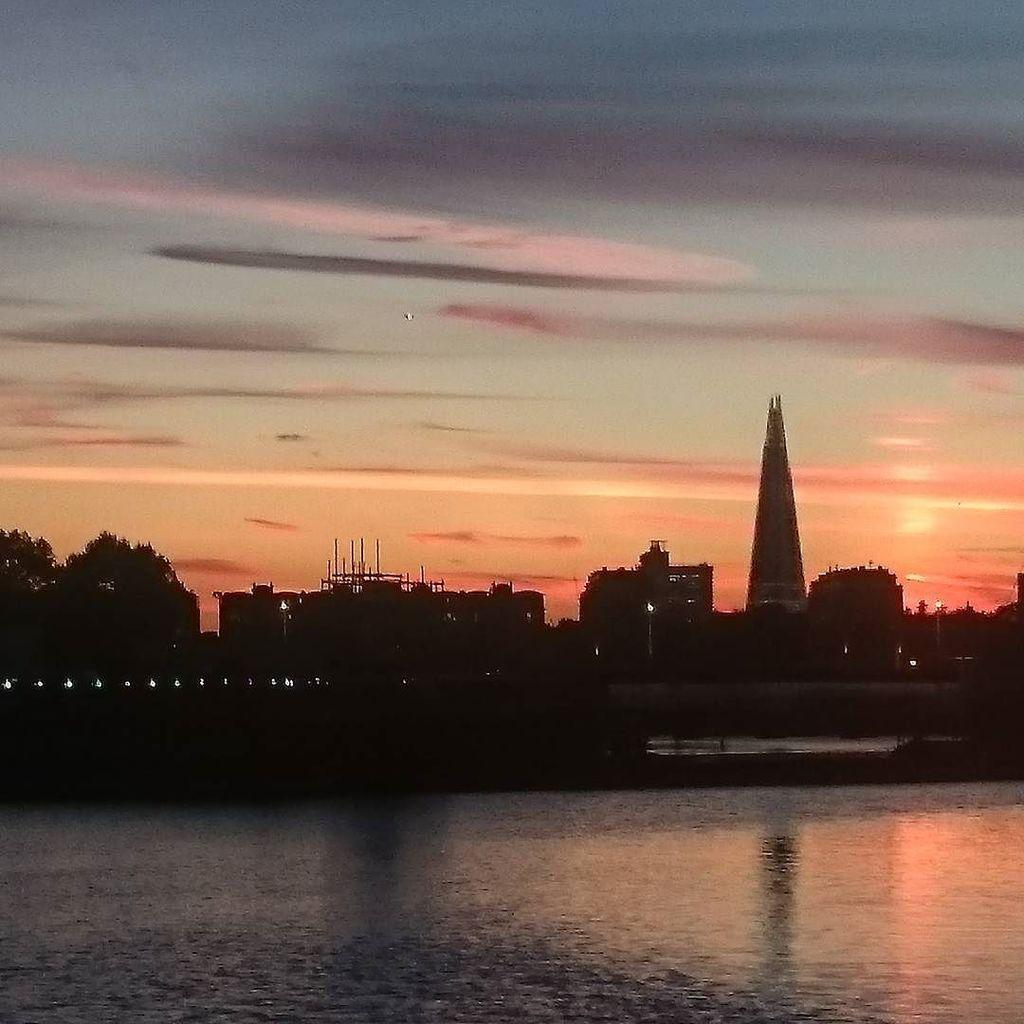What is located at the bottom of the picture? There is a river in the bottom of the picture. What can be seen in the background of the picture? There are trees, buildings, and clouds in the background of the picture. What type of pest can be seen crawling on the river in the image? There are no pests visible in the image, and the river is not a suitable environment for pests to crawl on. 